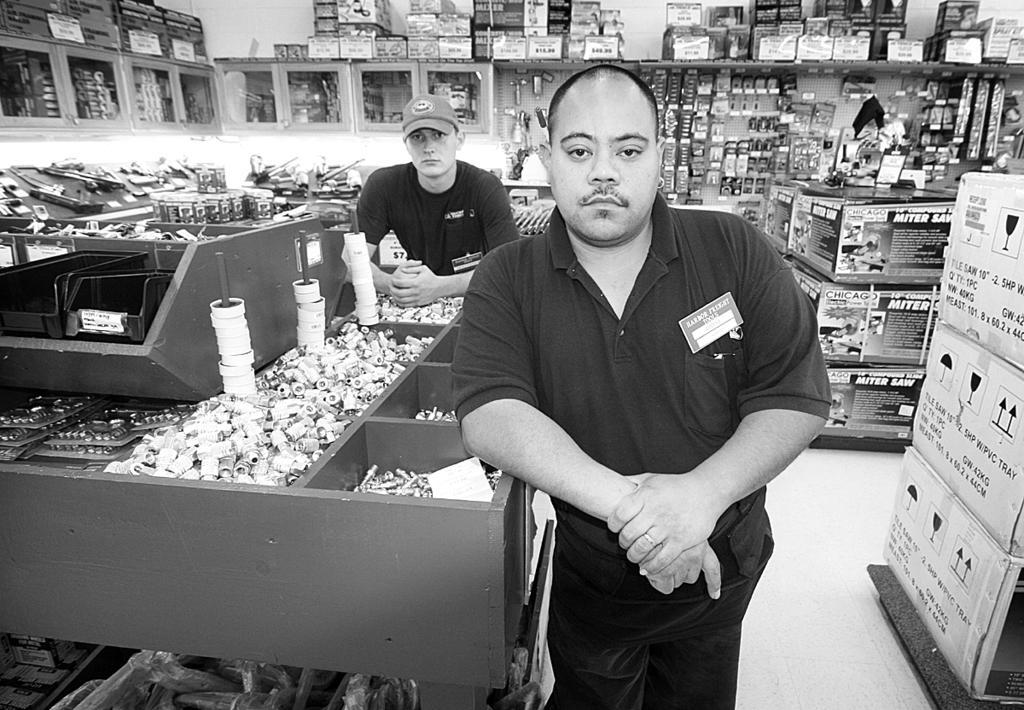Describe this image in one or two sentences. This is a black and white image. I can see two men standing. This picture was taken in a shop. There are objects, which are kept in the racks and cupboards. On the right side of the image, these are the cardboard boxes, which are placed on the floor. 